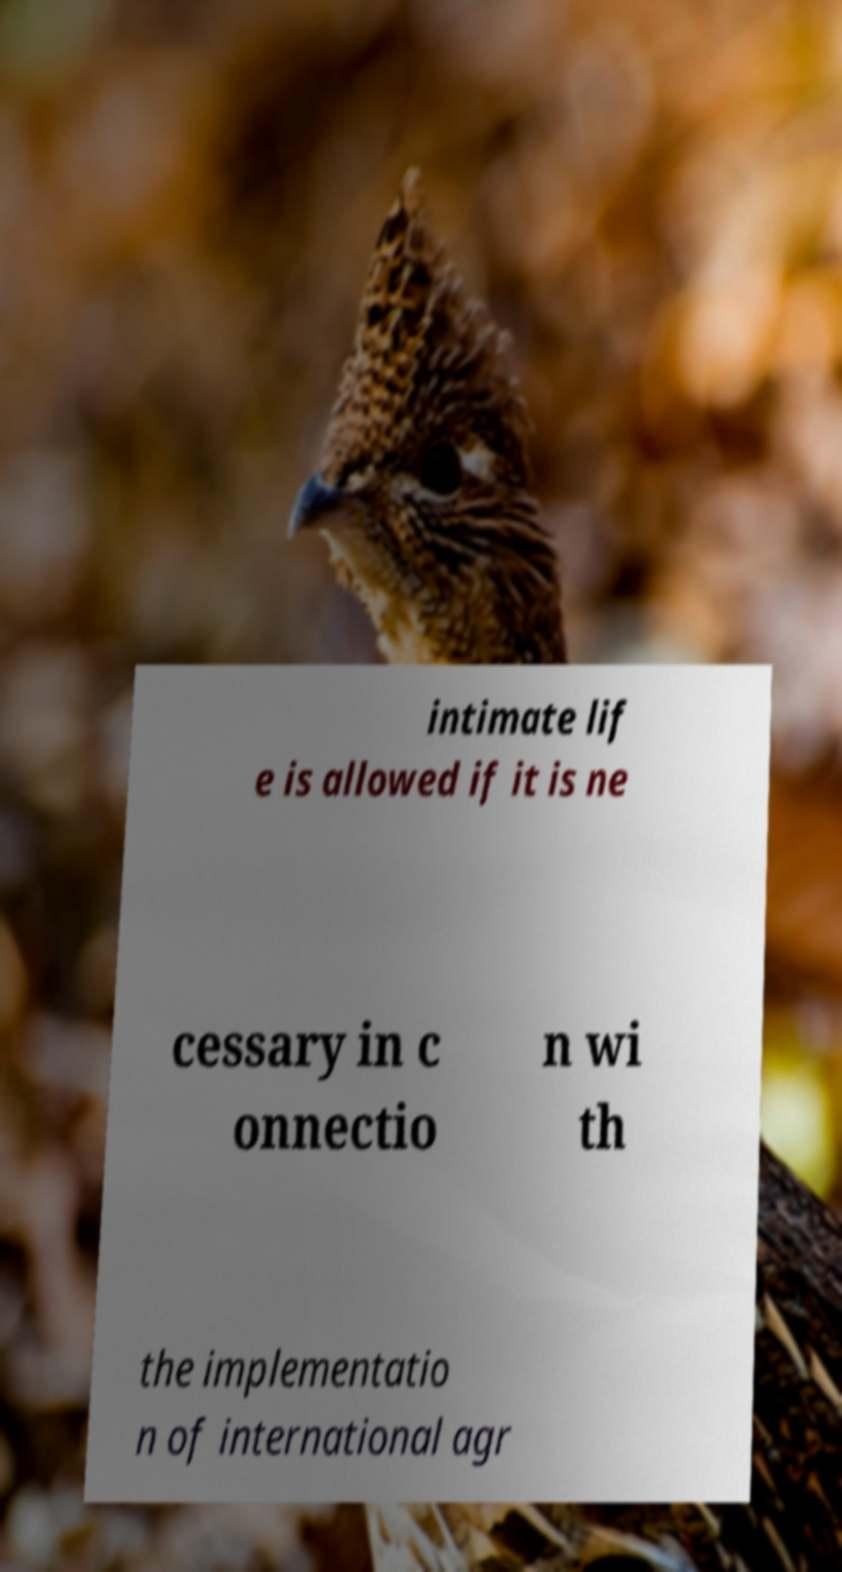There's text embedded in this image that I need extracted. Can you transcribe it verbatim? intimate lif e is allowed if it is ne cessary in c onnectio n wi th the implementatio n of international agr 